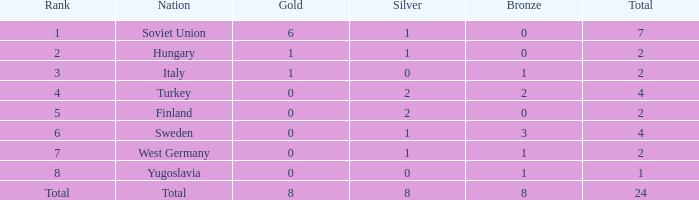What is the sum of Total, when Silver is 0, and when Gold is 1? 2.0. 